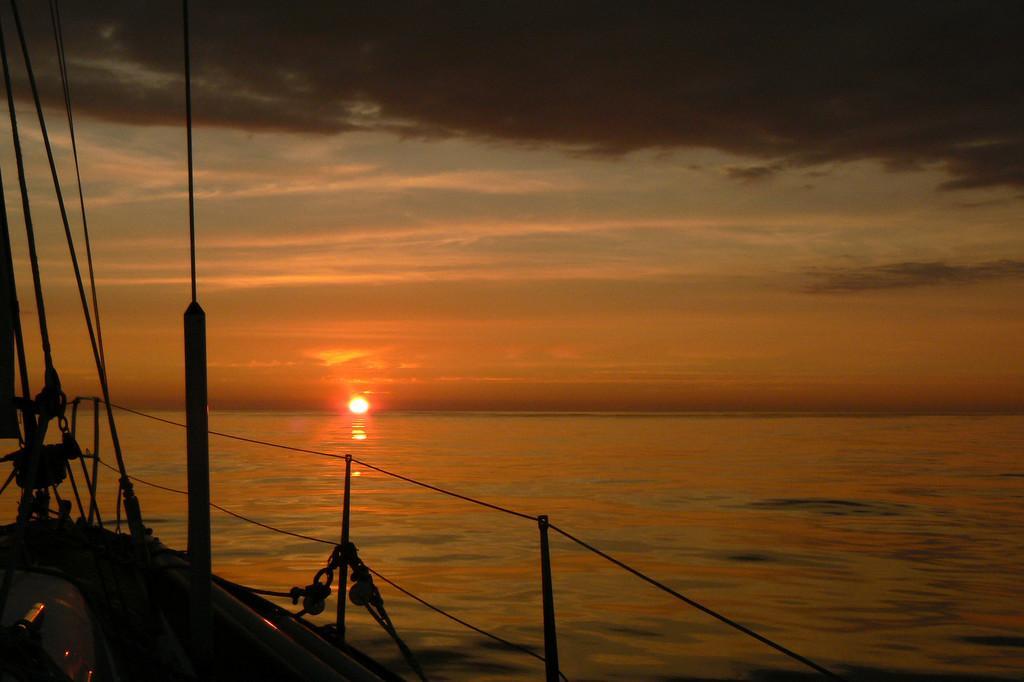Please provide a concise description of this image. This picture shows a boat in the water and we see sun in the sky and clouds. 